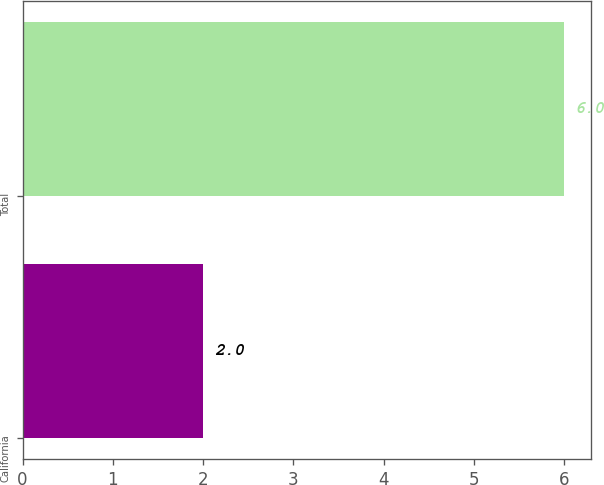Convert chart. <chart><loc_0><loc_0><loc_500><loc_500><bar_chart><fcel>California<fcel>Total<nl><fcel>2<fcel>6<nl></chart> 